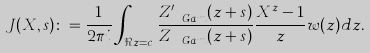Convert formula to latex. <formula><loc_0><loc_0><loc_500><loc_500>J ( X , s ) \colon = \frac { 1 } { 2 \pi i } \int _ { \Re { z } = c } \frac { Z ^ { \prime } _ { \ G a m } ( z + s ) } { Z _ { \ G a m } ( z + s ) } \frac { X ^ { z } - 1 } { z } w ( z ) d z .</formula> 